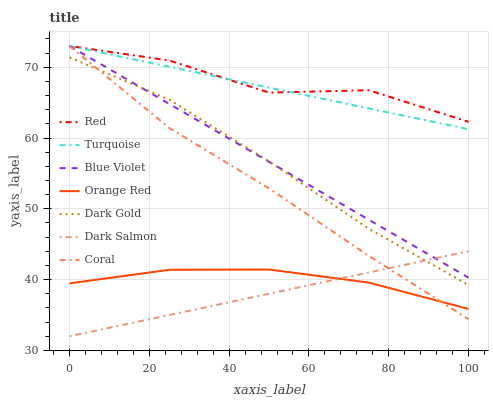Does Dark Gold have the minimum area under the curve?
Answer yes or no. No. Does Dark Gold have the maximum area under the curve?
Answer yes or no. No. Is Dark Gold the smoothest?
Answer yes or no. No. Is Dark Gold the roughest?
Answer yes or no. No. Does Dark Gold have the lowest value?
Answer yes or no. No. Does Dark Gold have the highest value?
Answer yes or no. No. Is Orange Red less than Red?
Answer yes or no. Yes. Is Turquoise greater than Orange Red?
Answer yes or no. Yes. Does Orange Red intersect Red?
Answer yes or no. No. 